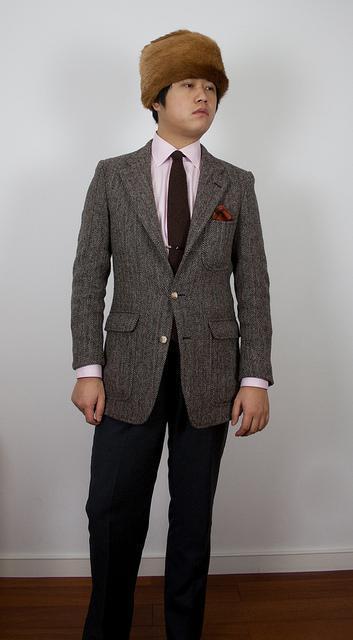How many buttons are closed?
Give a very brief answer. 1. How many people are on their laptop in this image?
Give a very brief answer. 0. 